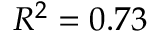<formula> <loc_0><loc_0><loc_500><loc_500>R ^ { 2 } = 0 . 7 3</formula> 